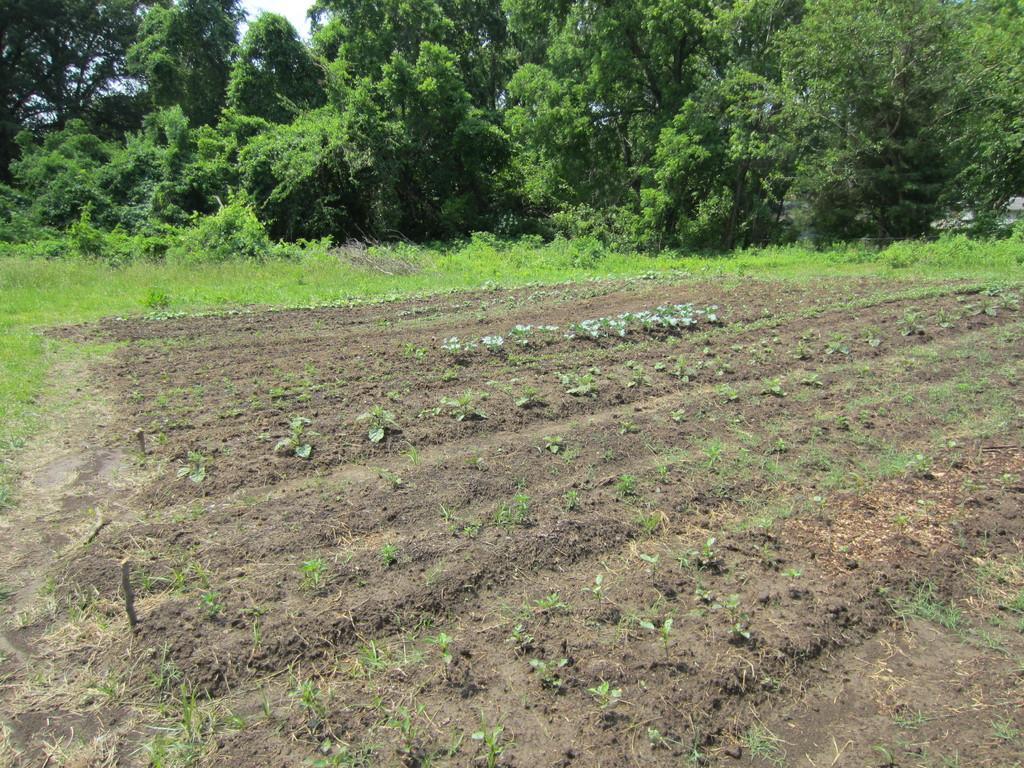Could you give a brief overview of what you see in this image? In this image I can see the ground, few plants on the ground and some grass. In the background I can see few trees and the sky. 